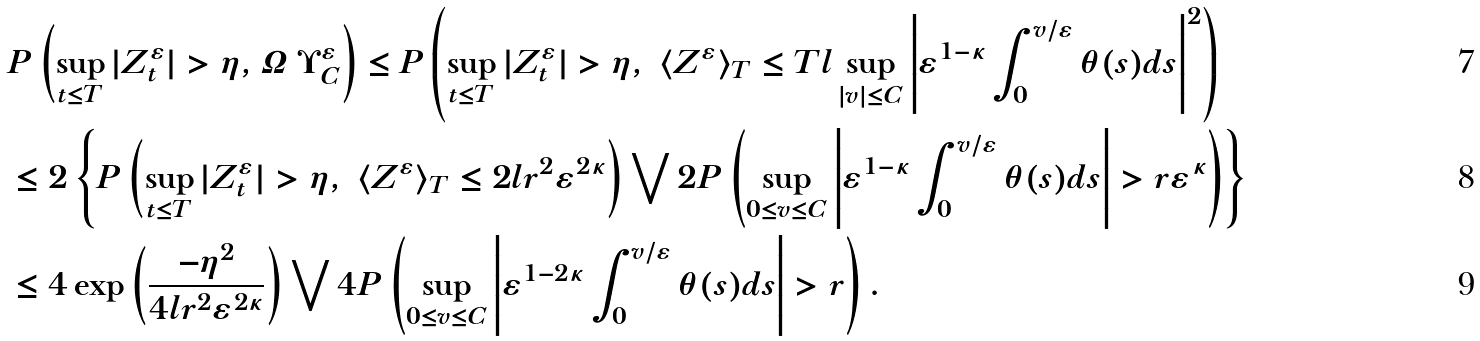<formula> <loc_0><loc_0><loc_500><loc_500>& P \left ( \sup _ { t \leq T } | Z ^ { \varepsilon } _ { t } | > \eta , \varOmega \ \Upsilon ^ { \varepsilon } _ { C } \right ) \leq P \left ( \sup _ { t \leq T } | Z ^ { \varepsilon } _ { t } | > \eta , \ \langle Z ^ { \varepsilon } \rangle _ { T } \leq T l \sup _ { | v | \leq C } \left | \varepsilon ^ { 1 - \kappa } \int _ { 0 } ^ { v / \varepsilon } \theta ( s ) d s \right | ^ { 2 } \right ) \\ & \leq 2 \left \{ P \left ( \sup _ { t \leq T } | Z ^ { \varepsilon } _ { t } | > \eta , \ \langle Z ^ { \varepsilon } \rangle _ { T } \leq 2 l r ^ { 2 } \varepsilon ^ { 2 \kappa } \right ) \bigvee 2 P \left ( \sup _ { 0 \leq v \leq C } \left | \varepsilon ^ { 1 - \kappa } \int _ { 0 } ^ { v / \varepsilon } \theta ( s ) d s \right | > r \varepsilon ^ { \kappa } \right ) \right \} \\ & \leq 4 \exp \left ( \frac { - \eta ^ { 2 } } { 4 l r ^ { 2 } \varepsilon ^ { 2 \kappa } } \right ) \bigvee 4 P \left ( \sup _ { 0 \leq v \leq C } \left | \varepsilon ^ { 1 - 2 \kappa } \int _ { 0 } ^ { v / \varepsilon } \theta ( s ) d s \right | > r \right ) .</formula> 